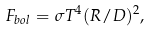<formula> <loc_0><loc_0><loc_500><loc_500>F _ { b o l } = \sigma T ^ { 4 } ( R / D ) ^ { 2 } ,</formula> 